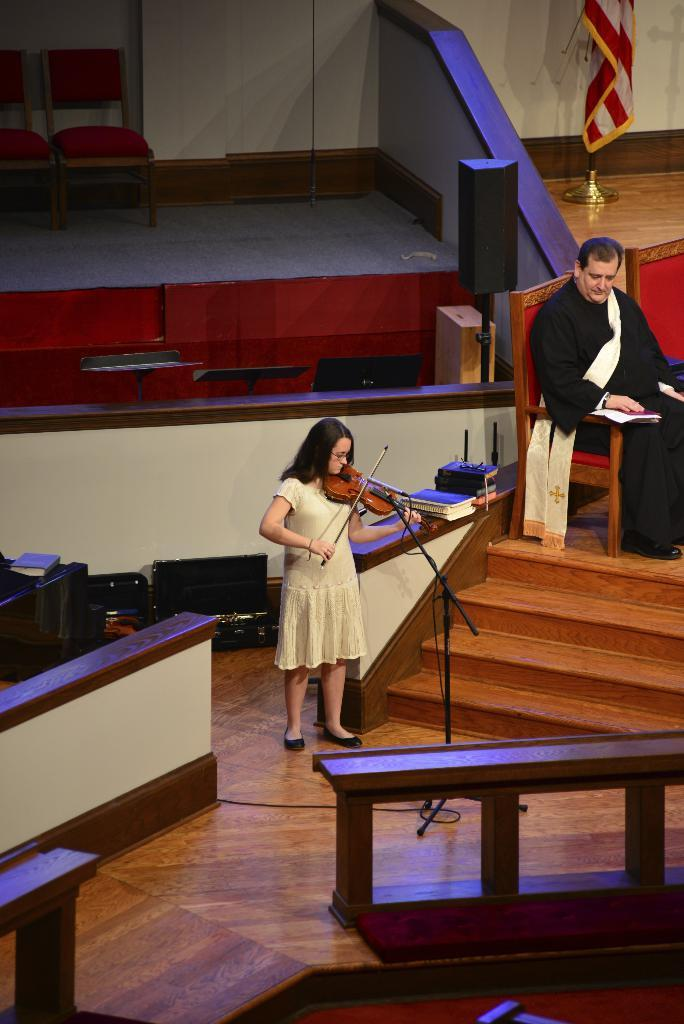Who is the main subject in the image? There is a woman in the image. What is the woman doing in the image? The woman is standing and playing a violin. Can you describe the man in the background of the image? The man is sitting on a chair in the background of the image. What is the man's relation to the woman in the image? The facts provided do not give information about the man's relation to the woman. What is the flag in the background of the image? There is a flag in the background of the image. What type of fish can be seen swimming in the background of the image? There is no fish present in the image; it features a woman playing a violin and a man sitting on a chair in the background. What school subject is being taught in the image? The image does not depict a school setting or any teaching activity. 